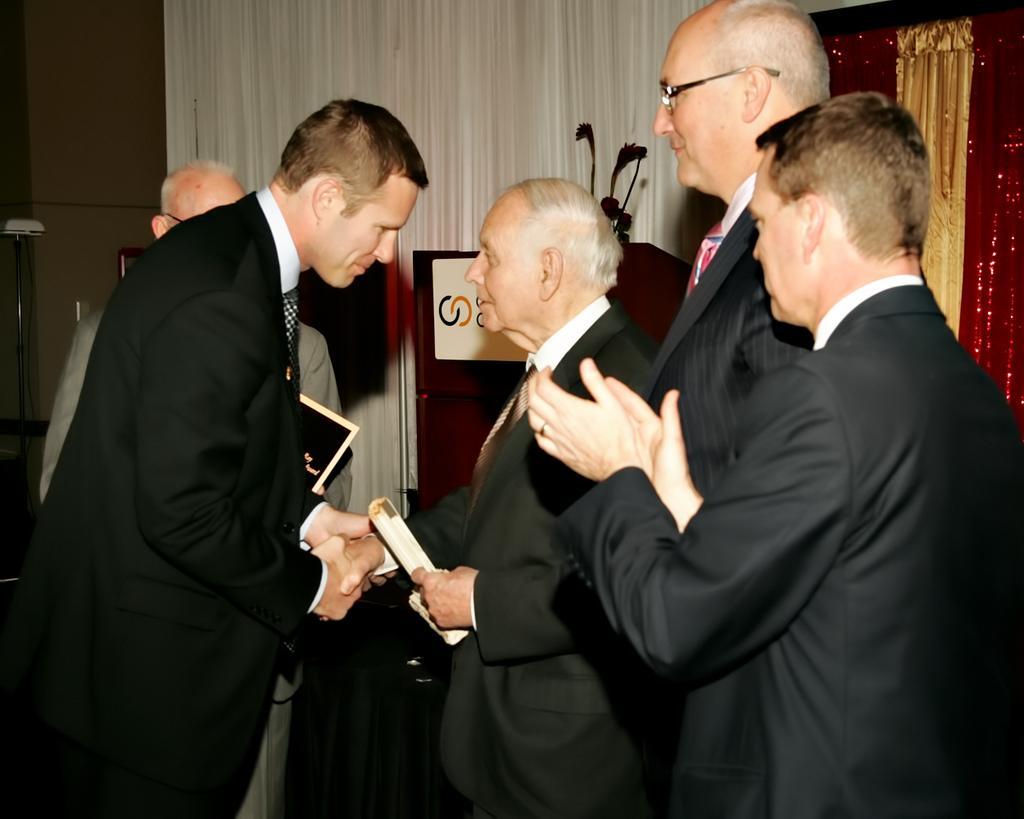Can you describe this image briefly? These people wore suits. These two people are giving shake-hand. Here we can see a podium. These are curtains. 